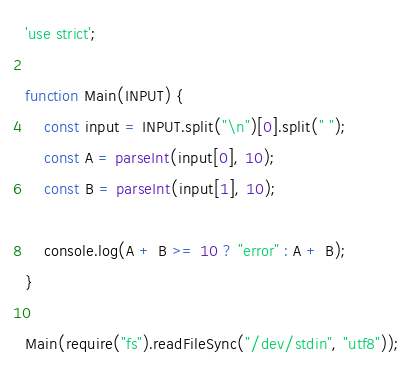Convert code to text. <code><loc_0><loc_0><loc_500><loc_500><_JavaScript_>'use strict';

function Main(INPUT) {
    const input = INPUT.split("\n")[0].split(" ");
    const A = parseInt(input[0], 10);
    const B = parseInt(input[1], 10);

    console.log(A + B >= 10 ? "error" : A + B);
}

Main(require("fs").readFileSync("/dev/stdin", "utf8"));
</code> 